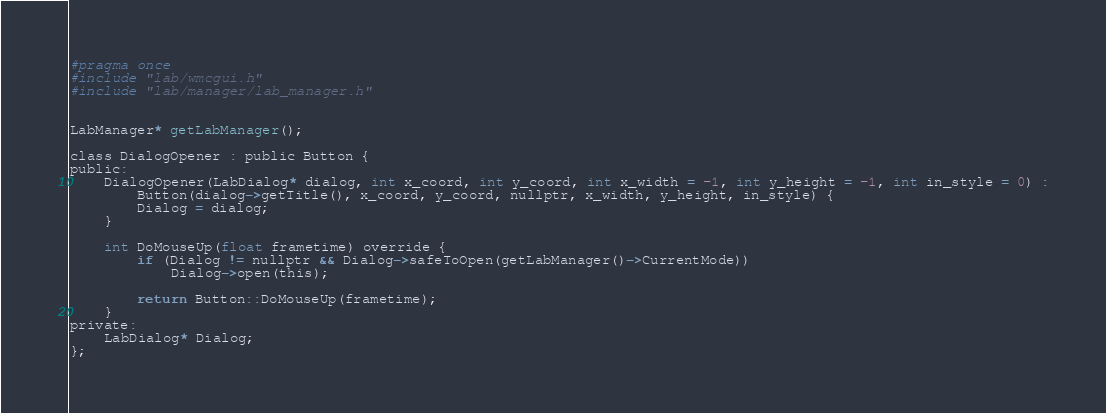Convert code to text. <code><loc_0><loc_0><loc_500><loc_500><_C_>#pragma once
#include "lab/wmcgui.h"
#include "lab/manager/lab_manager.h"


LabManager* getLabManager();

class DialogOpener : public Button {
public:
	DialogOpener(LabDialog* dialog, int x_coord, int y_coord, int x_width = -1, int y_height = -1, int in_style = 0) :
		Button(dialog->getTitle(), x_coord, y_coord, nullptr, x_width, y_height, in_style) {
		Dialog = dialog;
	}

	int DoMouseUp(float frametime) override {
		if (Dialog != nullptr && Dialog->safeToOpen(getLabManager()->CurrentMode))
			Dialog->open(this);

		return Button::DoMouseUp(frametime);
	}
private:
	LabDialog* Dialog;
};
</code> 